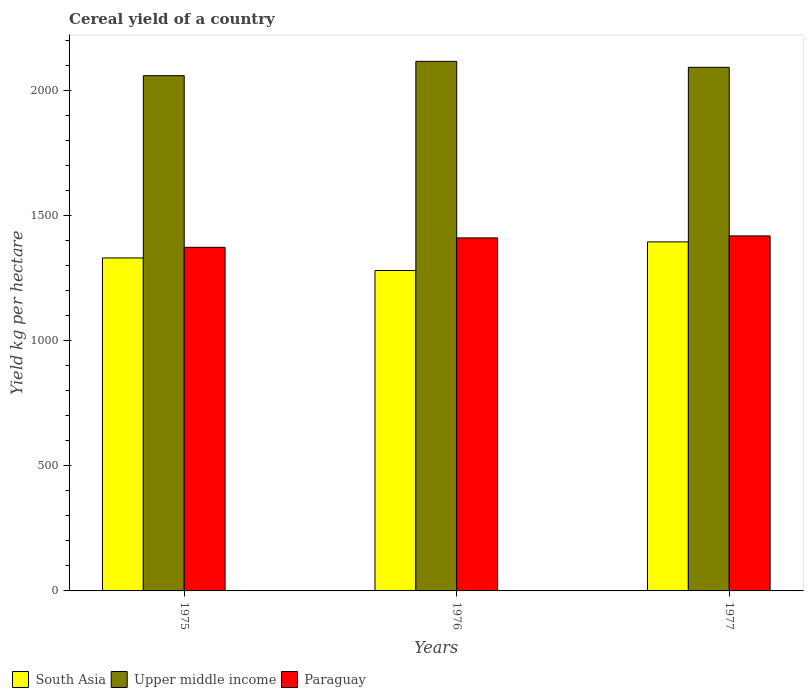Are the number of bars per tick equal to the number of legend labels?
Provide a succinct answer. Yes. Are the number of bars on each tick of the X-axis equal?
Your answer should be compact. Yes. How many bars are there on the 1st tick from the left?
Keep it short and to the point. 3. How many bars are there on the 2nd tick from the right?
Your answer should be compact. 3. What is the label of the 3rd group of bars from the left?
Your response must be concise. 1977. In how many cases, is the number of bars for a given year not equal to the number of legend labels?
Give a very brief answer. 0. What is the total cereal yield in South Asia in 1977?
Make the answer very short. 1394.98. Across all years, what is the maximum total cereal yield in Paraguay?
Give a very brief answer. 1418.9. Across all years, what is the minimum total cereal yield in Paraguay?
Provide a succinct answer. 1373.35. In which year was the total cereal yield in Upper middle income minimum?
Your response must be concise. 1975. What is the total total cereal yield in Upper middle income in the graph?
Provide a short and direct response. 6268.75. What is the difference between the total cereal yield in Upper middle income in 1975 and that in 1976?
Make the answer very short. -57.24. What is the difference between the total cereal yield in Paraguay in 1977 and the total cereal yield in Upper middle income in 1975?
Your answer should be compact. -640.46. What is the average total cereal yield in Paraguay per year?
Give a very brief answer. 1401.05. In the year 1976, what is the difference between the total cereal yield in Upper middle income and total cereal yield in Paraguay?
Your answer should be compact. 705.7. In how many years, is the total cereal yield in Paraguay greater than 200 kg per hectare?
Your answer should be very brief. 3. What is the ratio of the total cereal yield in Paraguay in 1975 to that in 1977?
Give a very brief answer. 0.97. Is the total cereal yield in Upper middle income in 1975 less than that in 1977?
Your answer should be compact. Yes. Is the difference between the total cereal yield in Upper middle income in 1975 and 1976 greater than the difference between the total cereal yield in Paraguay in 1975 and 1976?
Offer a terse response. No. What is the difference between the highest and the second highest total cereal yield in Paraguay?
Give a very brief answer. 8. What is the difference between the highest and the lowest total cereal yield in South Asia?
Give a very brief answer. 114.35. What does the 3rd bar from the left in 1977 represents?
Make the answer very short. Paraguay. Is it the case that in every year, the sum of the total cereal yield in South Asia and total cereal yield in Upper middle income is greater than the total cereal yield in Paraguay?
Give a very brief answer. Yes. Are all the bars in the graph horizontal?
Provide a succinct answer. No. How many years are there in the graph?
Make the answer very short. 3. What is the difference between two consecutive major ticks on the Y-axis?
Make the answer very short. 500. Does the graph contain grids?
Make the answer very short. No. Where does the legend appear in the graph?
Your response must be concise. Bottom left. How many legend labels are there?
Make the answer very short. 3. How are the legend labels stacked?
Your answer should be compact. Horizontal. What is the title of the graph?
Keep it short and to the point. Cereal yield of a country. What is the label or title of the Y-axis?
Provide a short and direct response. Yield kg per hectare. What is the Yield kg per hectare in South Asia in 1975?
Give a very brief answer. 1330.83. What is the Yield kg per hectare of Upper middle income in 1975?
Make the answer very short. 2059.36. What is the Yield kg per hectare of Paraguay in 1975?
Provide a succinct answer. 1373.35. What is the Yield kg per hectare of South Asia in 1976?
Ensure brevity in your answer.  1280.64. What is the Yield kg per hectare of Upper middle income in 1976?
Ensure brevity in your answer.  2116.6. What is the Yield kg per hectare in Paraguay in 1976?
Provide a succinct answer. 1410.9. What is the Yield kg per hectare in South Asia in 1977?
Keep it short and to the point. 1394.98. What is the Yield kg per hectare of Upper middle income in 1977?
Provide a succinct answer. 2092.79. What is the Yield kg per hectare of Paraguay in 1977?
Your answer should be very brief. 1418.9. Across all years, what is the maximum Yield kg per hectare of South Asia?
Give a very brief answer. 1394.98. Across all years, what is the maximum Yield kg per hectare of Upper middle income?
Ensure brevity in your answer.  2116.6. Across all years, what is the maximum Yield kg per hectare of Paraguay?
Ensure brevity in your answer.  1418.9. Across all years, what is the minimum Yield kg per hectare of South Asia?
Make the answer very short. 1280.64. Across all years, what is the minimum Yield kg per hectare in Upper middle income?
Make the answer very short. 2059.36. Across all years, what is the minimum Yield kg per hectare in Paraguay?
Provide a short and direct response. 1373.35. What is the total Yield kg per hectare in South Asia in the graph?
Provide a succinct answer. 4006.45. What is the total Yield kg per hectare of Upper middle income in the graph?
Provide a short and direct response. 6268.75. What is the total Yield kg per hectare in Paraguay in the graph?
Provide a short and direct response. 4203.15. What is the difference between the Yield kg per hectare in South Asia in 1975 and that in 1976?
Ensure brevity in your answer.  50.2. What is the difference between the Yield kg per hectare of Upper middle income in 1975 and that in 1976?
Give a very brief answer. -57.24. What is the difference between the Yield kg per hectare in Paraguay in 1975 and that in 1976?
Your response must be concise. -37.55. What is the difference between the Yield kg per hectare of South Asia in 1975 and that in 1977?
Ensure brevity in your answer.  -64.15. What is the difference between the Yield kg per hectare in Upper middle income in 1975 and that in 1977?
Provide a succinct answer. -33.43. What is the difference between the Yield kg per hectare in Paraguay in 1975 and that in 1977?
Provide a short and direct response. -45.55. What is the difference between the Yield kg per hectare in South Asia in 1976 and that in 1977?
Offer a terse response. -114.35. What is the difference between the Yield kg per hectare in Upper middle income in 1976 and that in 1977?
Give a very brief answer. 23.82. What is the difference between the Yield kg per hectare of Paraguay in 1976 and that in 1977?
Give a very brief answer. -8. What is the difference between the Yield kg per hectare of South Asia in 1975 and the Yield kg per hectare of Upper middle income in 1976?
Your response must be concise. -785.77. What is the difference between the Yield kg per hectare of South Asia in 1975 and the Yield kg per hectare of Paraguay in 1976?
Keep it short and to the point. -80.07. What is the difference between the Yield kg per hectare of Upper middle income in 1975 and the Yield kg per hectare of Paraguay in 1976?
Offer a terse response. 648.46. What is the difference between the Yield kg per hectare of South Asia in 1975 and the Yield kg per hectare of Upper middle income in 1977?
Offer a terse response. -761.95. What is the difference between the Yield kg per hectare in South Asia in 1975 and the Yield kg per hectare in Paraguay in 1977?
Offer a very short reply. -88.07. What is the difference between the Yield kg per hectare in Upper middle income in 1975 and the Yield kg per hectare in Paraguay in 1977?
Offer a very short reply. 640.46. What is the difference between the Yield kg per hectare of South Asia in 1976 and the Yield kg per hectare of Upper middle income in 1977?
Your response must be concise. -812.15. What is the difference between the Yield kg per hectare of South Asia in 1976 and the Yield kg per hectare of Paraguay in 1977?
Provide a succinct answer. -138.26. What is the difference between the Yield kg per hectare in Upper middle income in 1976 and the Yield kg per hectare in Paraguay in 1977?
Your answer should be very brief. 697.7. What is the average Yield kg per hectare of South Asia per year?
Provide a short and direct response. 1335.48. What is the average Yield kg per hectare in Upper middle income per year?
Offer a very short reply. 2089.58. What is the average Yield kg per hectare in Paraguay per year?
Offer a very short reply. 1401.05. In the year 1975, what is the difference between the Yield kg per hectare of South Asia and Yield kg per hectare of Upper middle income?
Offer a very short reply. -728.53. In the year 1975, what is the difference between the Yield kg per hectare in South Asia and Yield kg per hectare in Paraguay?
Offer a terse response. -42.52. In the year 1975, what is the difference between the Yield kg per hectare of Upper middle income and Yield kg per hectare of Paraguay?
Ensure brevity in your answer.  686.01. In the year 1976, what is the difference between the Yield kg per hectare of South Asia and Yield kg per hectare of Upper middle income?
Give a very brief answer. -835.97. In the year 1976, what is the difference between the Yield kg per hectare of South Asia and Yield kg per hectare of Paraguay?
Provide a short and direct response. -130.27. In the year 1976, what is the difference between the Yield kg per hectare of Upper middle income and Yield kg per hectare of Paraguay?
Keep it short and to the point. 705.7. In the year 1977, what is the difference between the Yield kg per hectare of South Asia and Yield kg per hectare of Upper middle income?
Your answer should be very brief. -697.81. In the year 1977, what is the difference between the Yield kg per hectare in South Asia and Yield kg per hectare in Paraguay?
Ensure brevity in your answer.  -23.92. In the year 1977, what is the difference between the Yield kg per hectare of Upper middle income and Yield kg per hectare of Paraguay?
Ensure brevity in your answer.  673.89. What is the ratio of the Yield kg per hectare of South Asia in 1975 to that in 1976?
Your answer should be very brief. 1.04. What is the ratio of the Yield kg per hectare of Paraguay in 1975 to that in 1976?
Make the answer very short. 0.97. What is the ratio of the Yield kg per hectare in South Asia in 1975 to that in 1977?
Your answer should be compact. 0.95. What is the ratio of the Yield kg per hectare of Paraguay in 1975 to that in 1977?
Give a very brief answer. 0.97. What is the ratio of the Yield kg per hectare of South Asia in 1976 to that in 1977?
Your response must be concise. 0.92. What is the ratio of the Yield kg per hectare in Upper middle income in 1976 to that in 1977?
Your answer should be very brief. 1.01. What is the ratio of the Yield kg per hectare in Paraguay in 1976 to that in 1977?
Offer a terse response. 0.99. What is the difference between the highest and the second highest Yield kg per hectare in South Asia?
Offer a terse response. 64.15. What is the difference between the highest and the second highest Yield kg per hectare in Upper middle income?
Offer a very short reply. 23.82. What is the difference between the highest and the second highest Yield kg per hectare of Paraguay?
Your answer should be very brief. 8. What is the difference between the highest and the lowest Yield kg per hectare of South Asia?
Your response must be concise. 114.35. What is the difference between the highest and the lowest Yield kg per hectare of Upper middle income?
Your answer should be compact. 57.24. What is the difference between the highest and the lowest Yield kg per hectare in Paraguay?
Your answer should be compact. 45.55. 